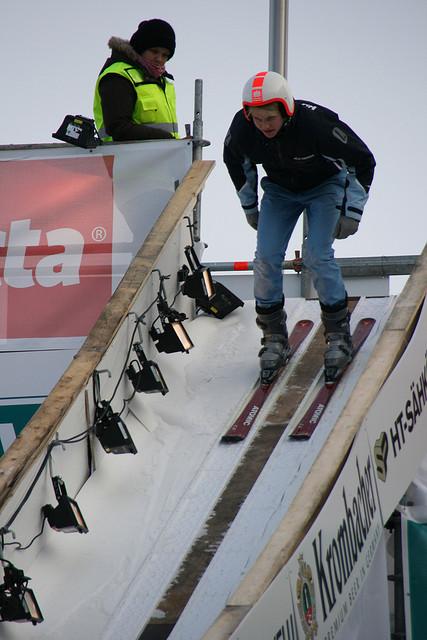Why doesn't he have ski poles?
Concise answer only. He's going down ramp. What color is the man's helmet?
Be succinct. White and orange. Is he wearing jeans?
Write a very short answer. Yes. 